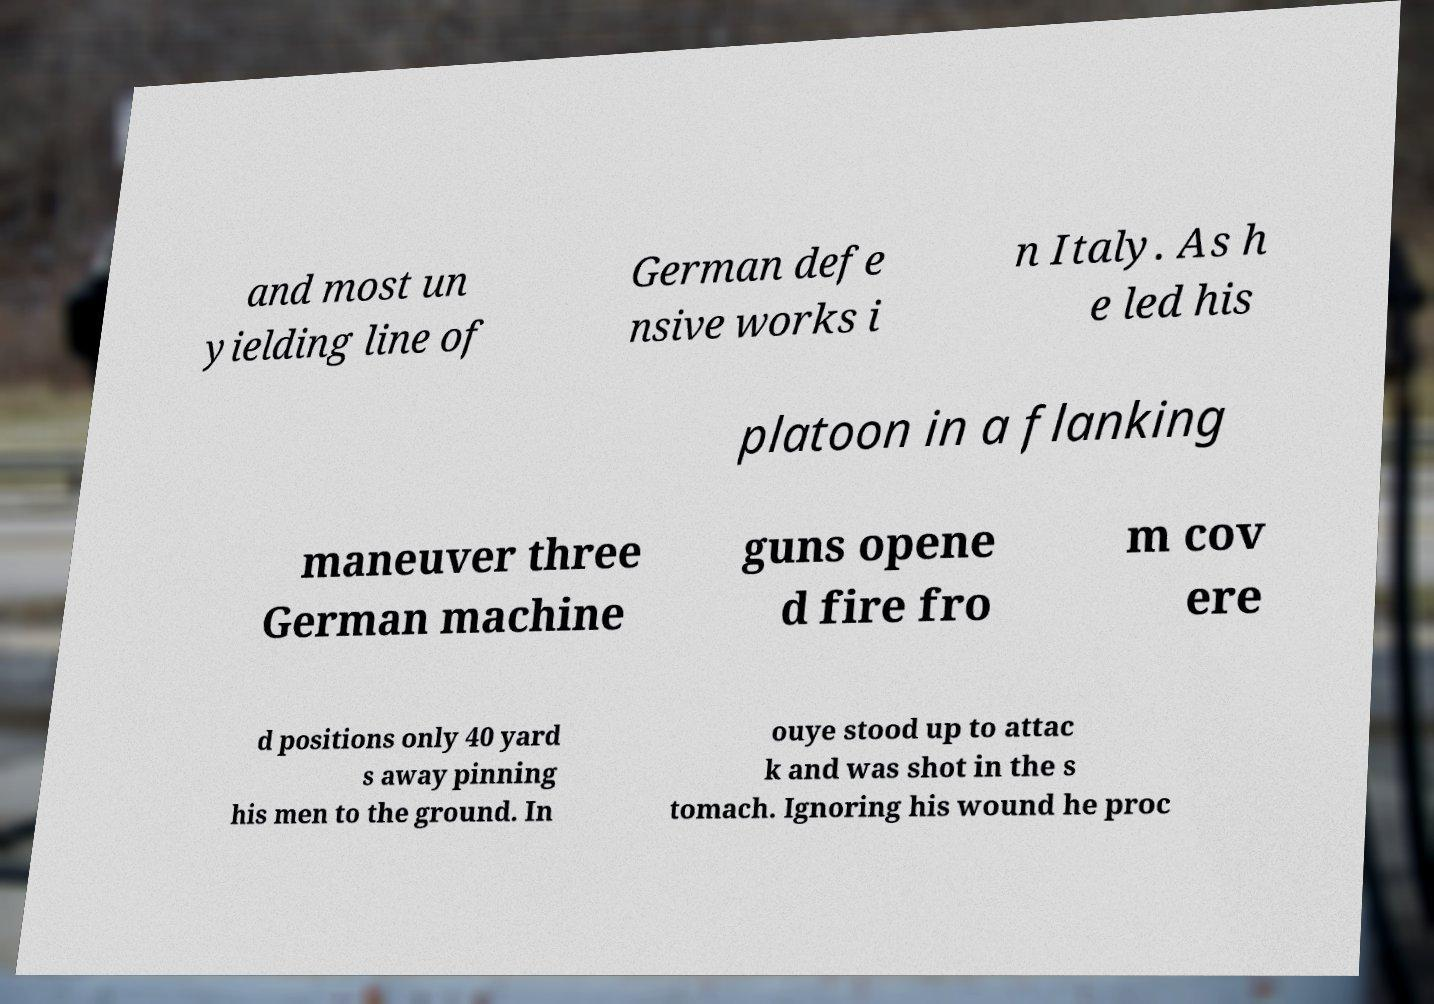There's text embedded in this image that I need extracted. Can you transcribe it verbatim? and most un yielding line of German defe nsive works i n Italy. As h e led his platoon in a flanking maneuver three German machine guns opene d fire fro m cov ere d positions only 40 yard s away pinning his men to the ground. In ouye stood up to attac k and was shot in the s tomach. Ignoring his wound he proc 